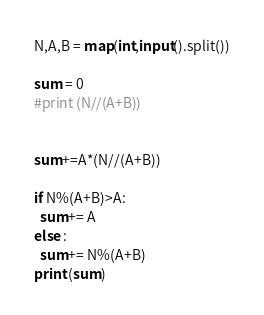<code> <loc_0><loc_0><loc_500><loc_500><_Python_>N,A,B = map(int,input().split())

sum = 0
#print (N//(A+B))


sum+=A*(N//(A+B))

if N%(A+B)>A:
  sum+= A
else :
  sum+= N%(A+B)
print (sum)</code> 